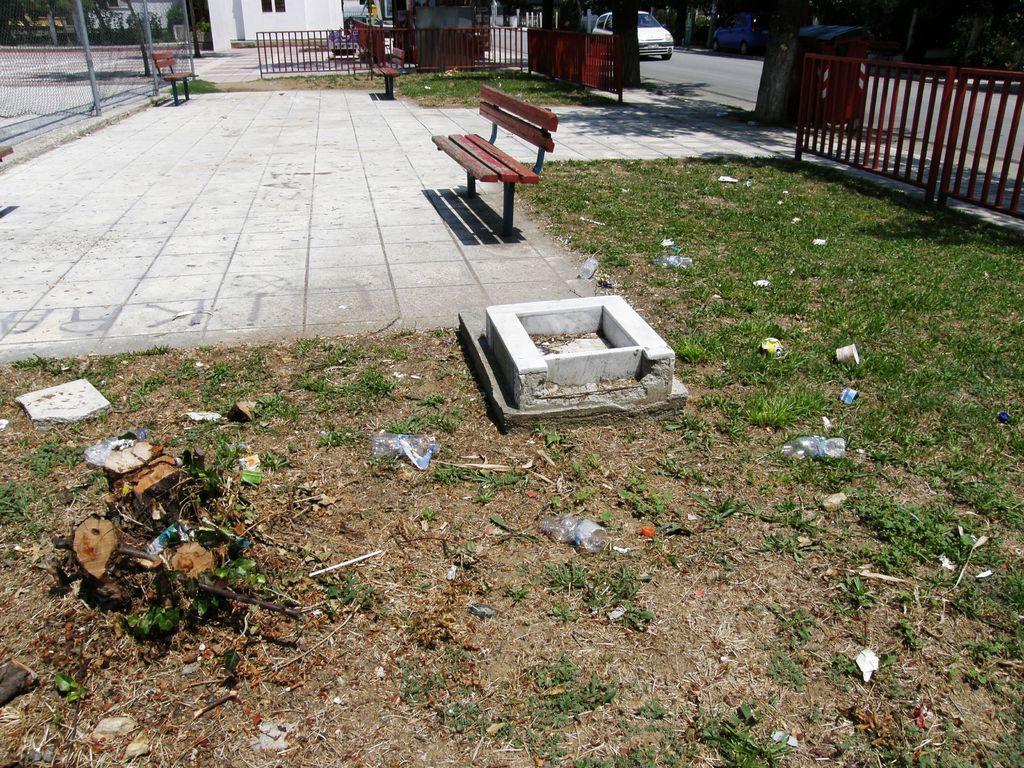Please provide a concise description of this image. In this picture we can see grass and some garbage at the bottom, there are two benches in the middle, we can see fencing panel on the right side, there is a car traveling on the road, in the background there is a house, we can see trees at the left top of the picture. 